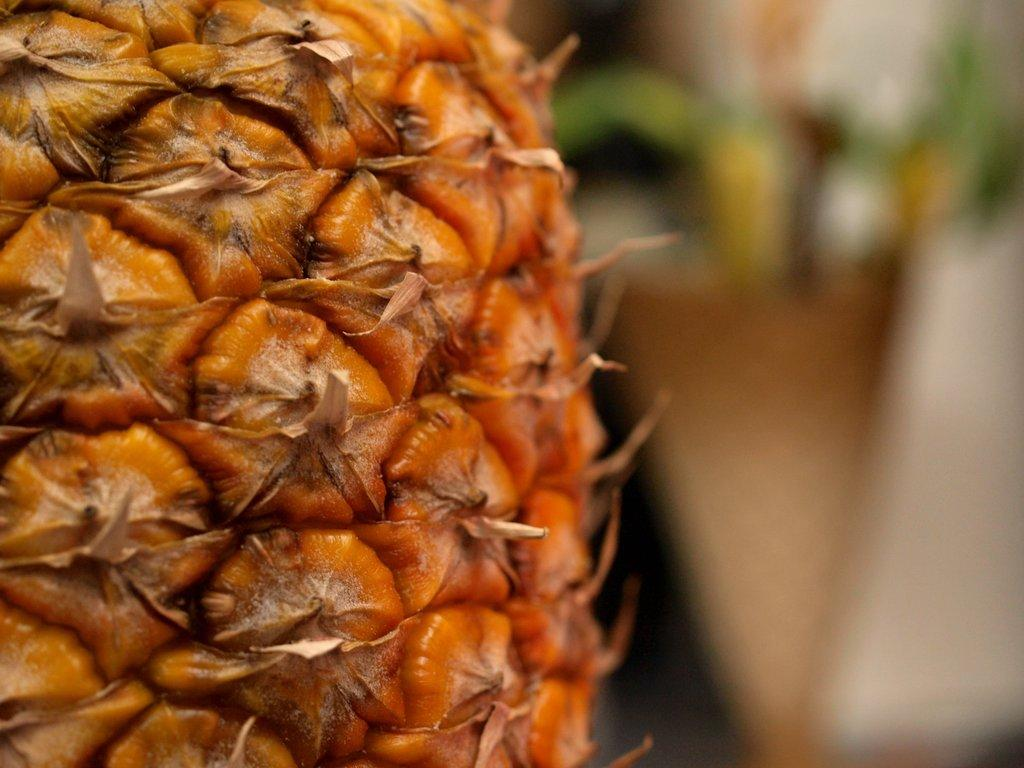What is the main subject of the image? There is a pineapple in the image. Can you describe the background of the image? The background of the image is blurry. Who is the owner of the pineapple in the image? There is no information about the owner of the pineapple in the image. What type of nest can be seen in the image? There is no nest present in the image. 